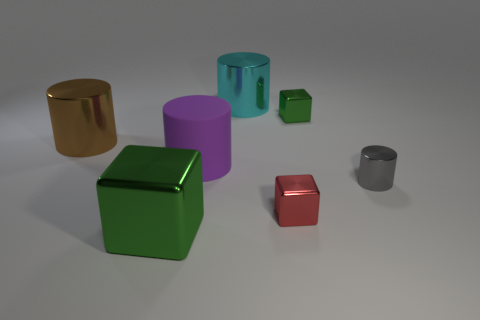There is a tiny thing that is the same color as the large cube; what is it made of?
Offer a very short reply. Metal. How many other things are the same color as the small shiny cylinder?
Your answer should be compact. 0. There is a big metal object in front of the gray metal object; is it the same shape as the green metallic thing that is behind the small gray shiny object?
Ensure brevity in your answer.  Yes. How many objects are small gray objects behind the large green metal object or green cubes in front of the red metal block?
Provide a short and direct response. 2. What number of other things are made of the same material as the small green cube?
Provide a short and direct response. 5. Is the big thing that is in front of the large rubber object made of the same material as the tiny green block?
Offer a very short reply. Yes. Is the number of large purple objects that are behind the red metallic cube greater than the number of shiny cylinders left of the brown metallic cylinder?
Make the answer very short. Yes. How many objects are large brown cylinders behind the tiny red object or green cubes?
Provide a short and direct response. 3. What shape is the big green object that is the same material as the small red cube?
Make the answer very short. Cube. Is there anything else that has the same shape as the brown object?
Your response must be concise. Yes. 